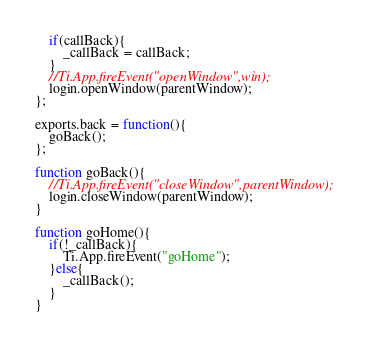<code> <loc_0><loc_0><loc_500><loc_500><_JavaScript_>	if(callBack){
		_callBack = callBack;
	}
	//Ti.App.fireEvent("openWindow",win);
	login.openWindow(parentWindow);
};

exports.back = function(){
	goBack();
};

function goBack(){
    //Ti.App.fireEvent("closeWindow",parentWindow);
    login.closeWindow(parentWindow);
}

function goHome(){
	if(!_callBack){
		Ti.App.fireEvent("goHome");
	}else{
		_callBack();
	}
}
</code> 